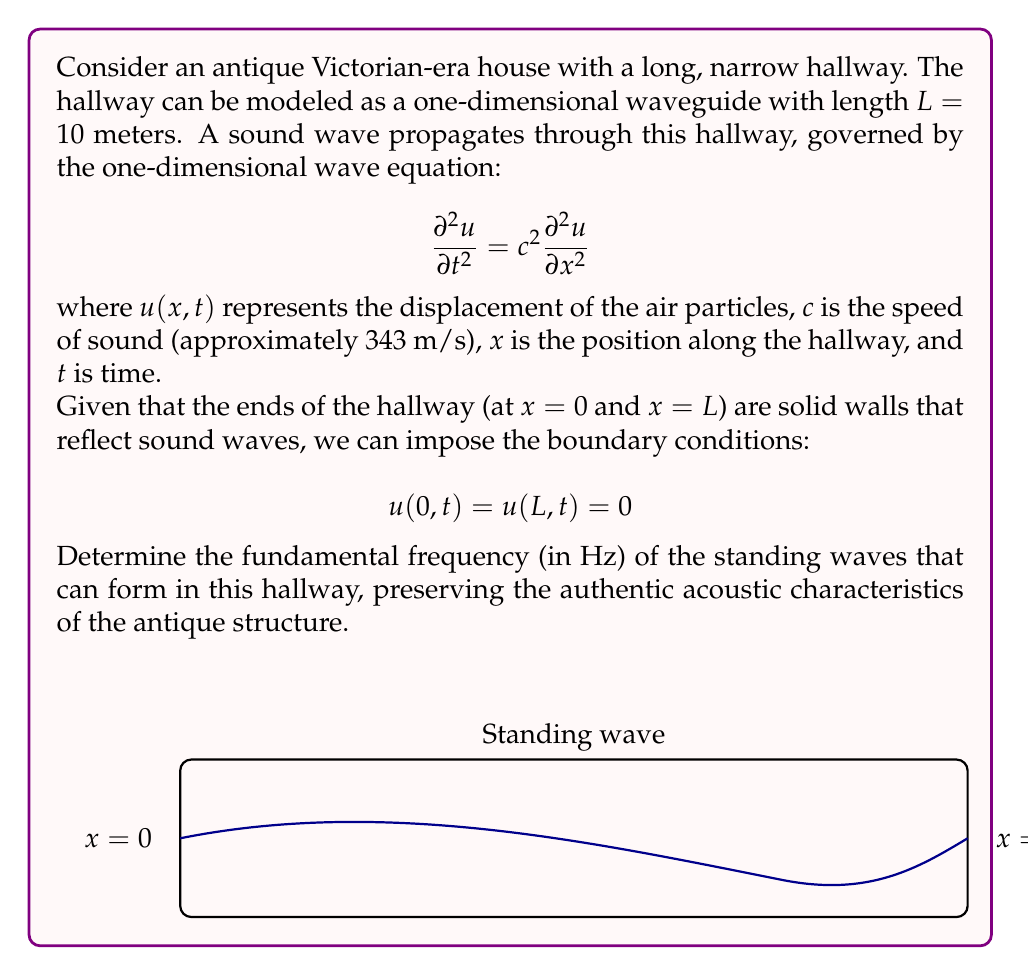Provide a solution to this math problem. To solve this problem, we'll follow these steps:

1) For standing waves in a one-dimensional waveguide with fixed ends, the general solution has the form:

   $$u(x,t) = A \sin(kx) \cos(\omega t)$$

   where $A$ is the amplitude, $k$ is the wave number, and $\omega$ is the angular frequency.

2) Applying the boundary conditions:
   At $x=0$: $u(0,t) = A \sin(0) \cos(\omega t) = 0$ (satisfied for all $t$)
   At $x=L$: $u(L,t) = A \sin(kL) \cos(\omega t) = 0$

3) For the condition at $x=L$ to be true for all $t$, we must have:

   $$\sin(kL) = 0$$

4) This is satisfied when $kL = n\pi$, where $n$ is a positive integer. Thus:

   $$k = \frac{n\pi}{L}$$

5) The relationship between wave number $k$, angular frequency $\omega$, and wave speed $c$ is:

   $$\omega = ck$$

6) Substituting the expression for $k$:

   $$\omega = c \frac{n\pi}{L}$$

7) The frequency $f$ is related to $\omega$ by $\omega = 2\pi f$. Thus:

   $$f = \frac{c}{2L} n$$

8) The fundamental frequency corresponds to $n=1$. Substituting the given values:

   $$f_1 = \frac{343 \text{ m/s}}{2(10 \text{ m})} = 17.15 \text{ Hz}$$

This frequency represents the lowest-pitched standing wave that can form in the hallway, preserving its authentic acoustic characteristics.
Answer: 17.15 Hz 